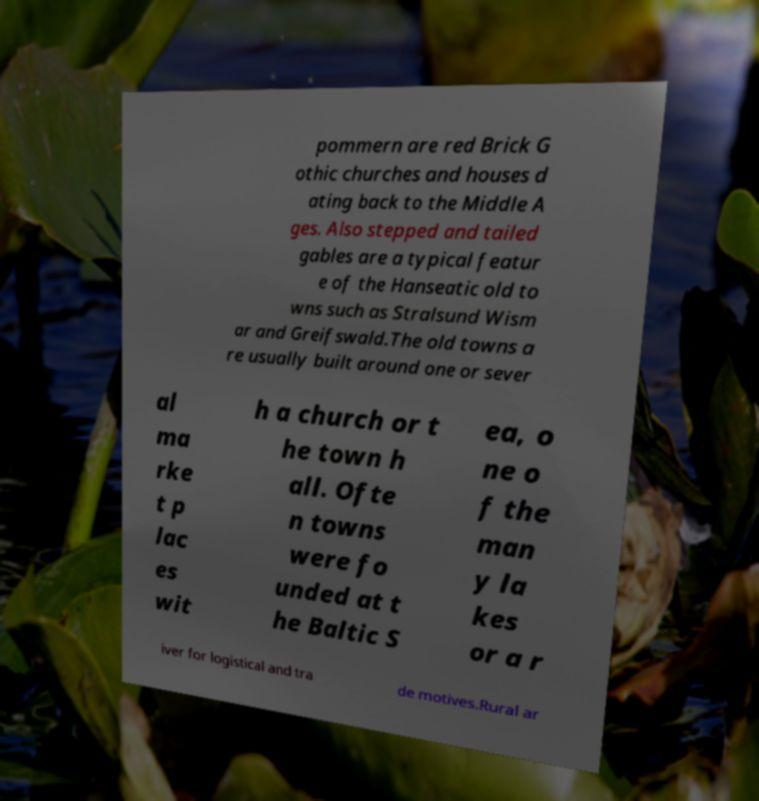Could you extract and type out the text from this image? pommern are red Brick G othic churches and houses d ating back to the Middle A ges. Also stepped and tailed gables are a typical featur e of the Hanseatic old to wns such as Stralsund Wism ar and Greifswald.The old towns a re usually built around one or sever al ma rke t p lac es wit h a church or t he town h all. Ofte n towns were fo unded at t he Baltic S ea, o ne o f the man y la kes or a r iver for logistical and tra de motives.Rural ar 